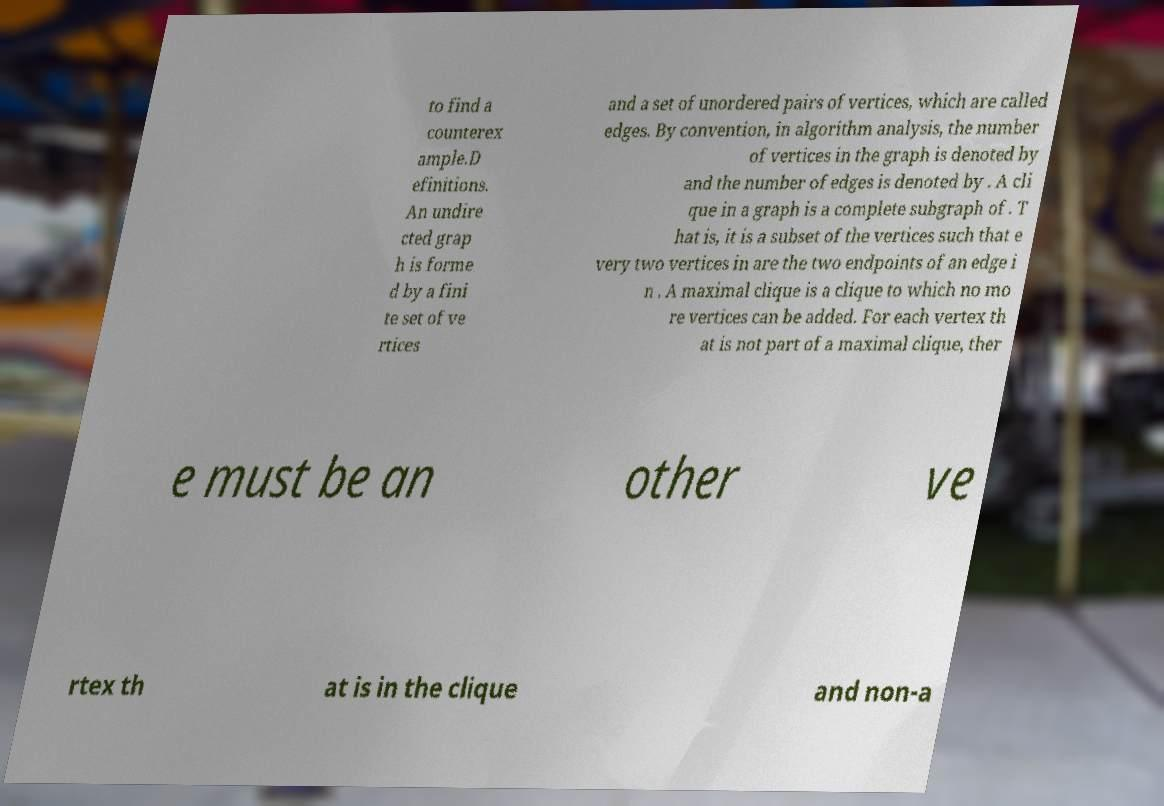Can you accurately transcribe the text from the provided image for me? to find a counterex ample.D efinitions. An undire cted grap h is forme d by a fini te set of ve rtices and a set of unordered pairs of vertices, which are called edges. By convention, in algorithm analysis, the number of vertices in the graph is denoted by and the number of edges is denoted by . A cli que in a graph is a complete subgraph of . T hat is, it is a subset of the vertices such that e very two vertices in are the two endpoints of an edge i n . A maximal clique is a clique to which no mo re vertices can be added. For each vertex th at is not part of a maximal clique, ther e must be an other ve rtex th at is in the clique and non-a 